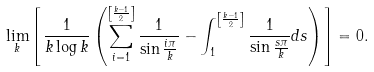<formula> <loc_0><loc_0><loc_500><loc_500>\lim _ { k } \left [ \frac { 1 } { k \log k } \left ( \sum _ { i = 1 } ^ { \left [ \frac { k - 1 } { 2 } \right ] } \frac { 1 } { \sin \frac { i \pi } { k } } - \int _ { 1 } ^ { \left [ \frac { k - 1 } { 2 } \right ] } \frac { 1 } { \sin \frac { s \pi } { k } } d s \right ) \right ] = 0 .</formula> 